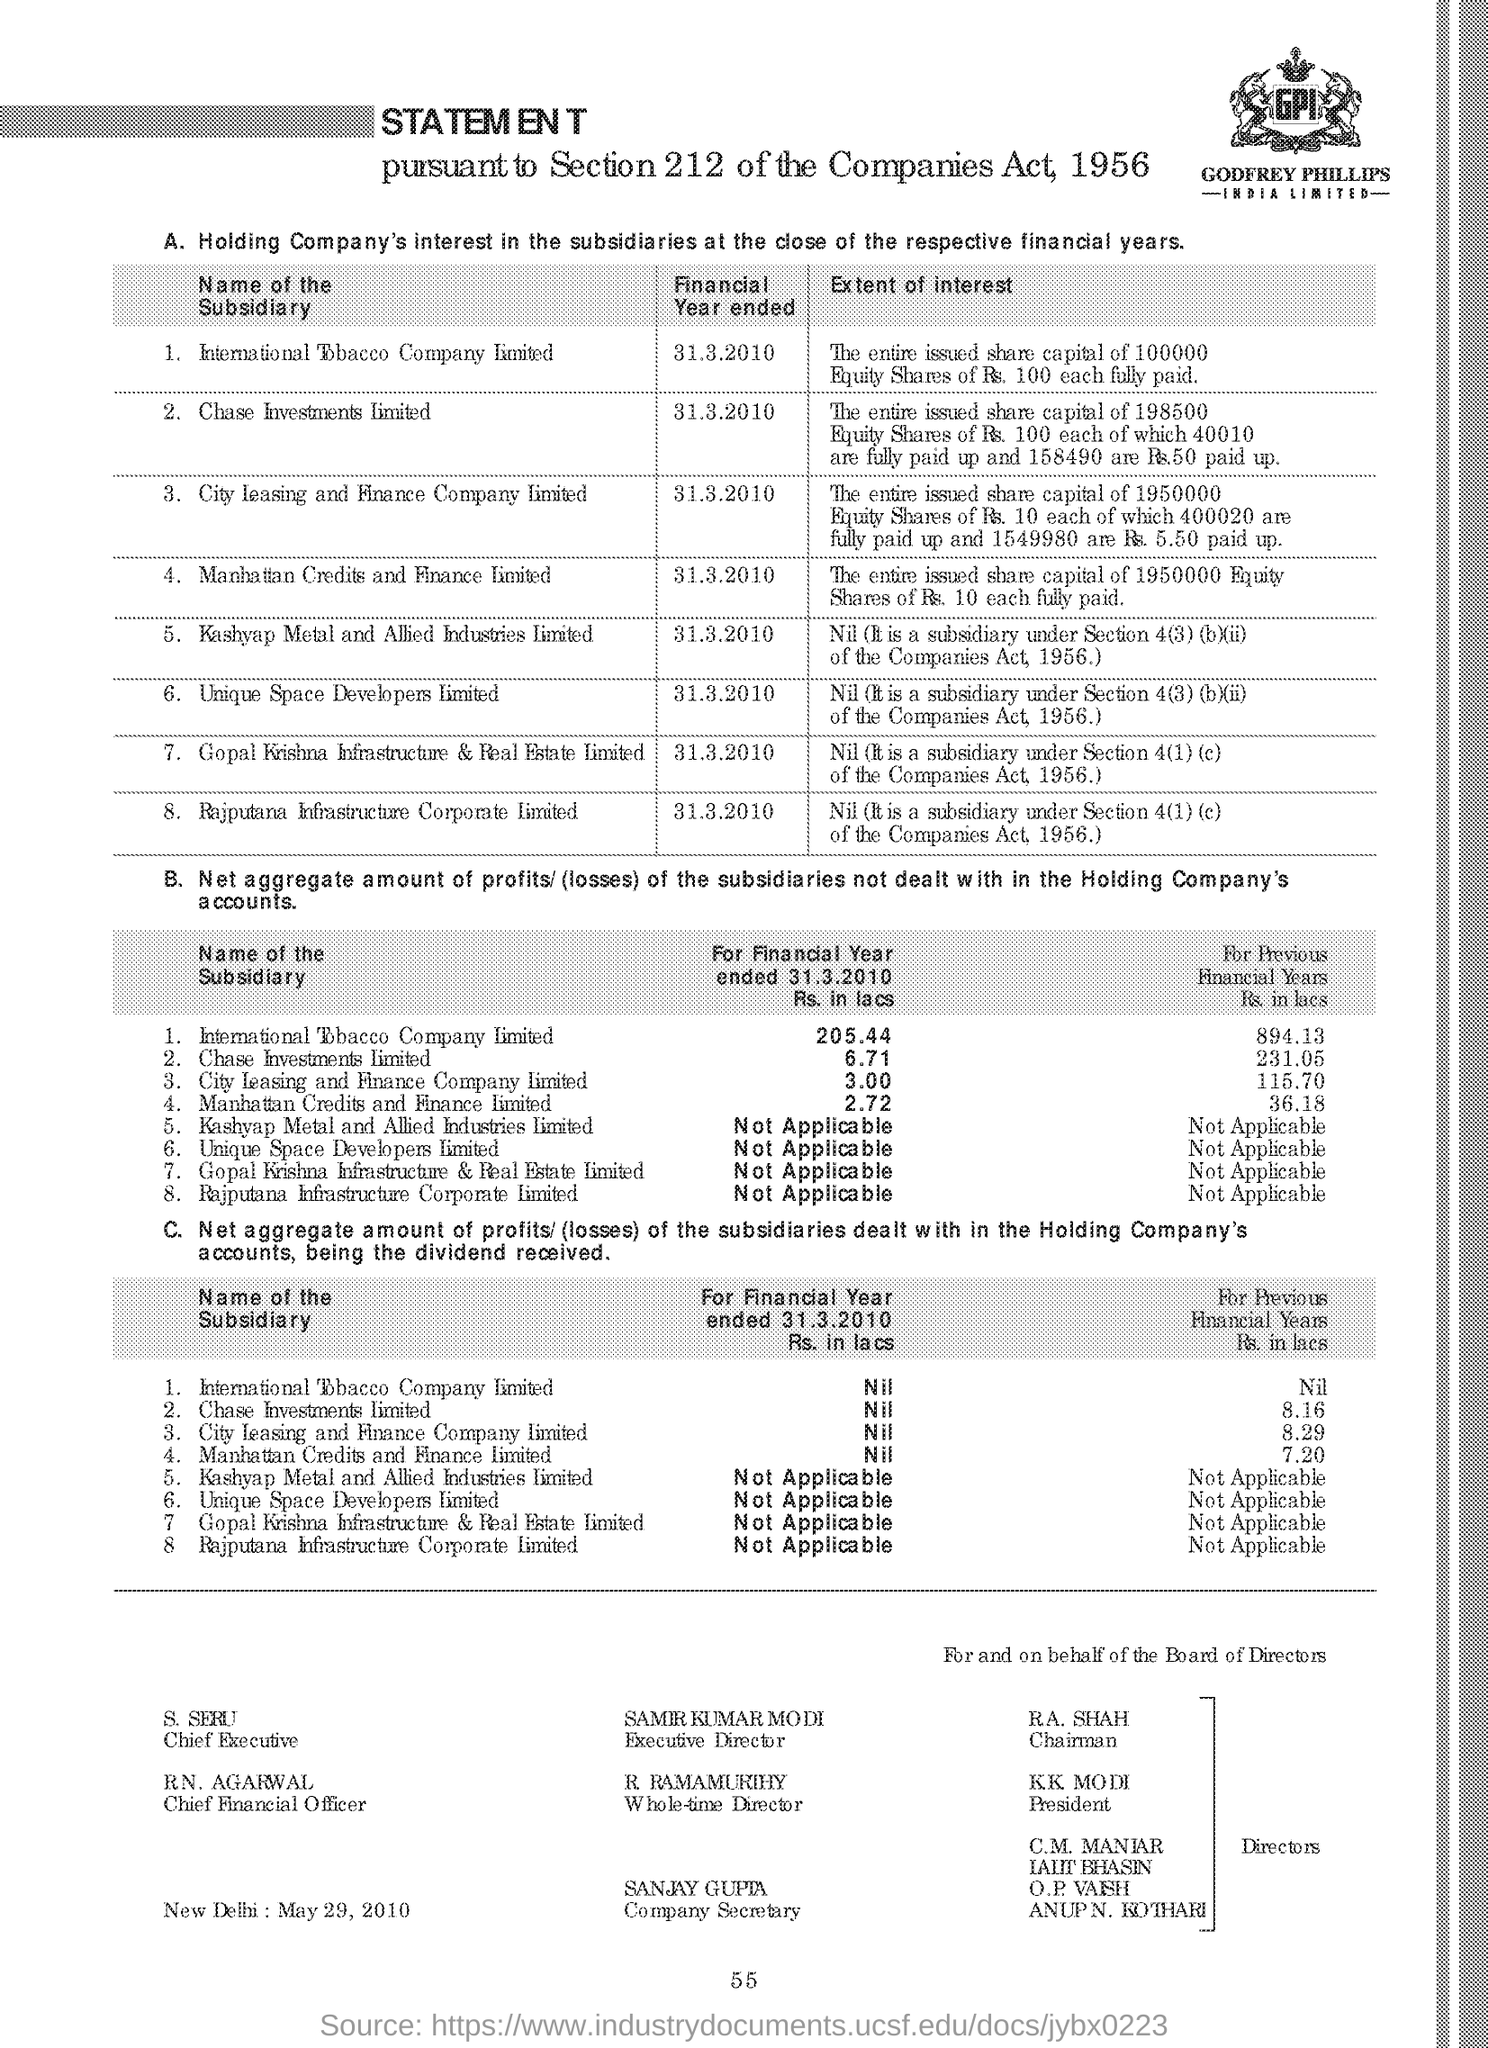Who is the executive director ?
Make the answer very short. Samir Kumar modi. Who is the company secretary ?
Your answer should be compact. Sanjay gupta. Who is the chairman ?
Provide a short and direct response. R.A. SHAH. Who is the whole time director ?
Offer a very short reply. R. Ramamurthy. Who is the chief financial officer ?
Provide a short and direct response. R N. Agarwal. Who is the president ?
Give a very brief answer. K.K. Modi. When is the financial year ended for the international tobacco company ?
Make the answer very short. 31.3.2010. 